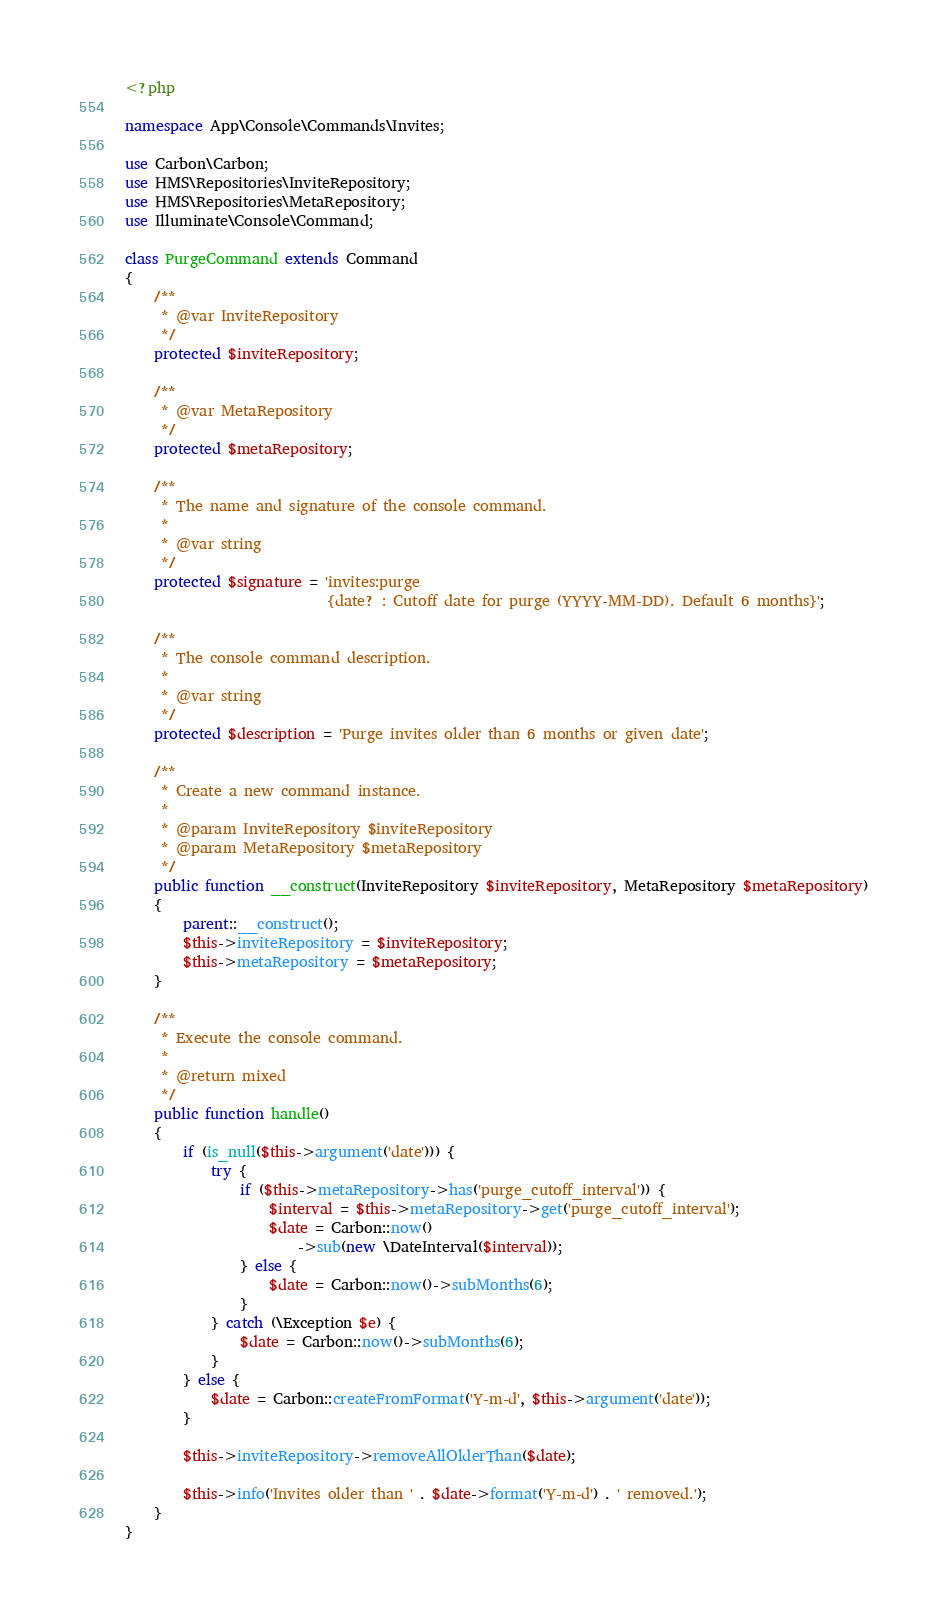<code> <loc_0><loc_0><loc_500><loc_500><_PHP_><?php

namespace App\Console\Commands\Invites;

use Carbon\Carbon;
use HMS\Repositories\InviteRepository;
use HMS\Repositories\MetaRepository;
use Illuminate\Console\Command;

class PurgeCommand extends Command
{
    /**
     * @var InviteRepository
     */
    protected $inviteRepository;

    /**
     * @var MetaRepository
     */
    protected $metaRepository;

    /**
     * The name and signature of the console command.
     *
     * @var string
     */
    protected $signature = 'invites:purge
                            {date? : Cutoff date for purge (YYYY-MM-DD). Default 6 months}';

    /**
     * The console command description.
     *
     * @var string
     */
    protected $description = 'Purge invites older than 6 months or given date';

    /**
     * Create a new command instance.
     *
     * @param InviteRepository $inviteRepository
     * @param MetaRepository $metaRepository
     */
    public function __construct(InviteRepository $inviteRepository, MetaRepository $metaRepository)
    {
        parent::__construct();
        $this->inviteRepository = $inviteRepository;
        $this->metaRepository = $metaRepository;
    }

    /**
     * Execute the console command.
     *
     * @return mixed
     */
    public function handle()
    {
        if (is_null($this->argument('date'))) {
            try {
                if ($this->metaRepository->has('purge_cutoff_interval')) {
                    $interval = $this->metaRepository->get('purge_cutoff_interval');
                    $date = Carbon::now()
                        ->sub(new \DateInterval($interval));
                } else {
                    $date = Carbon::now()->subMonths(6);
                }
            } catch (\Exception $e) {
                $date = Carbon::now()->subMonths(6);
            }
        } else {
            $date = Carbon::createFromFormat('Y-m-d', $this->argument('date'));
        }

        $this->inviteRepository->removeAllOlderThan($date);

        $this->info('Invites older than ' . $date->format('Y-m-d') . ' removed.');
    }
}
</code> 